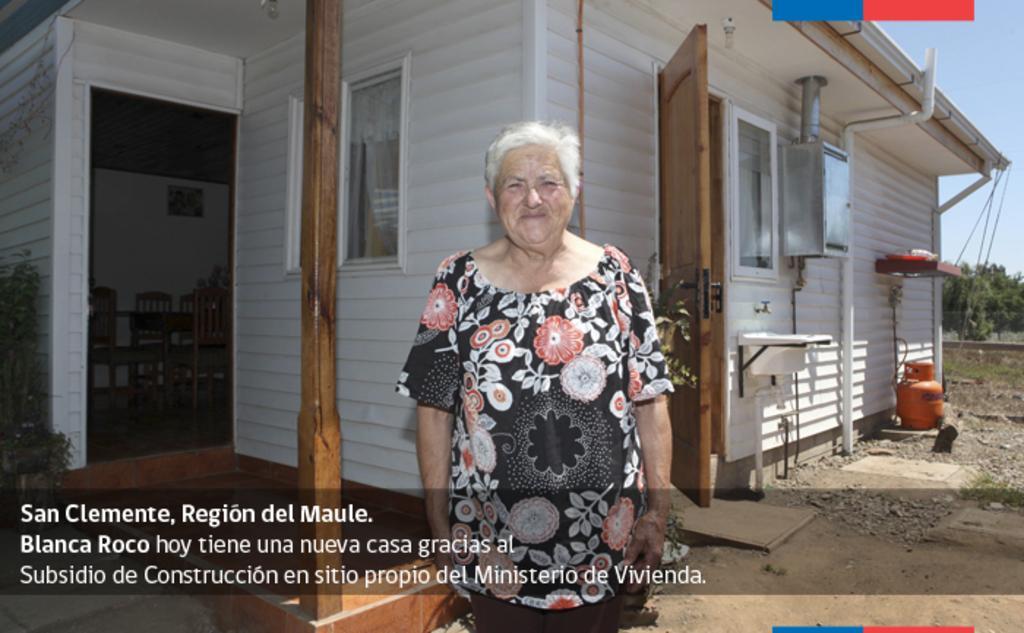Can you describe this image briefly? This is an advertisement. In the center of the image we can see a lady is standing. In the background of the image we can see the building, door, windows, sink, tap, cylinder, shelf, some objects, pipe, table, chairs, wall, board. On the left side of the image we can see a plant. On the right side of the image we can see the trees and some stones. At the bottom of the image we can see the ground and text. In the top right corner we can see the sky. 